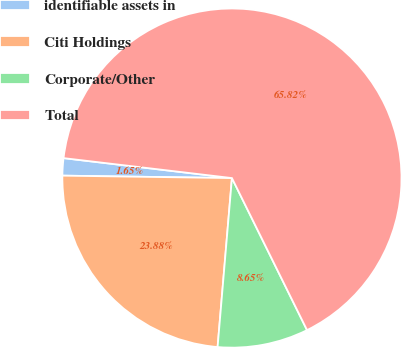Convert chart. <chart><loc_0><loc_0><loc_500><loc_500><pie_chart><fcel>identifiable assets in<fcel>Citi Holdings<fcel>Corporate/Other<fcel>Total<nl><fcel>1.65%<fcel>23.88%<fcel>8.65%<fcel>65.82%<nl></chart> 